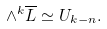<formula> <loc_0><loc_0><loc_500><loc_500>\wedge ^ { k } \overline { L } \simeq U _ { k - n } .</formula> 